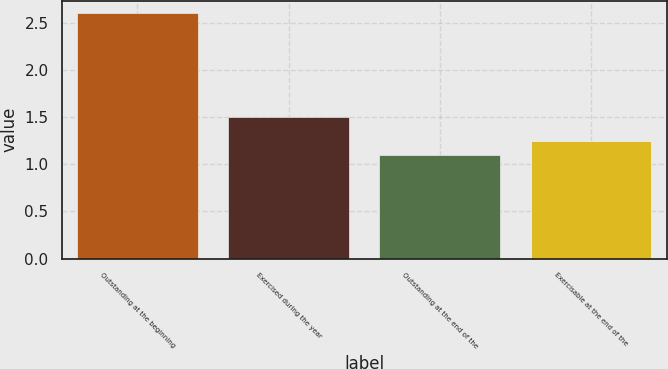Convert chart to OTSL. <chart><loc_0><loc_0><loc_500><loc_500><bar_chart><fcel>Outstanding at the beginning<fcel>Exercised during the year<fcel>Outstanding at the end of the<fcel>Exercisable at the end of the<nl><fcel>2.6<fcel>1.5<fcel>1.1<fcel>1.25<nl></chart> 